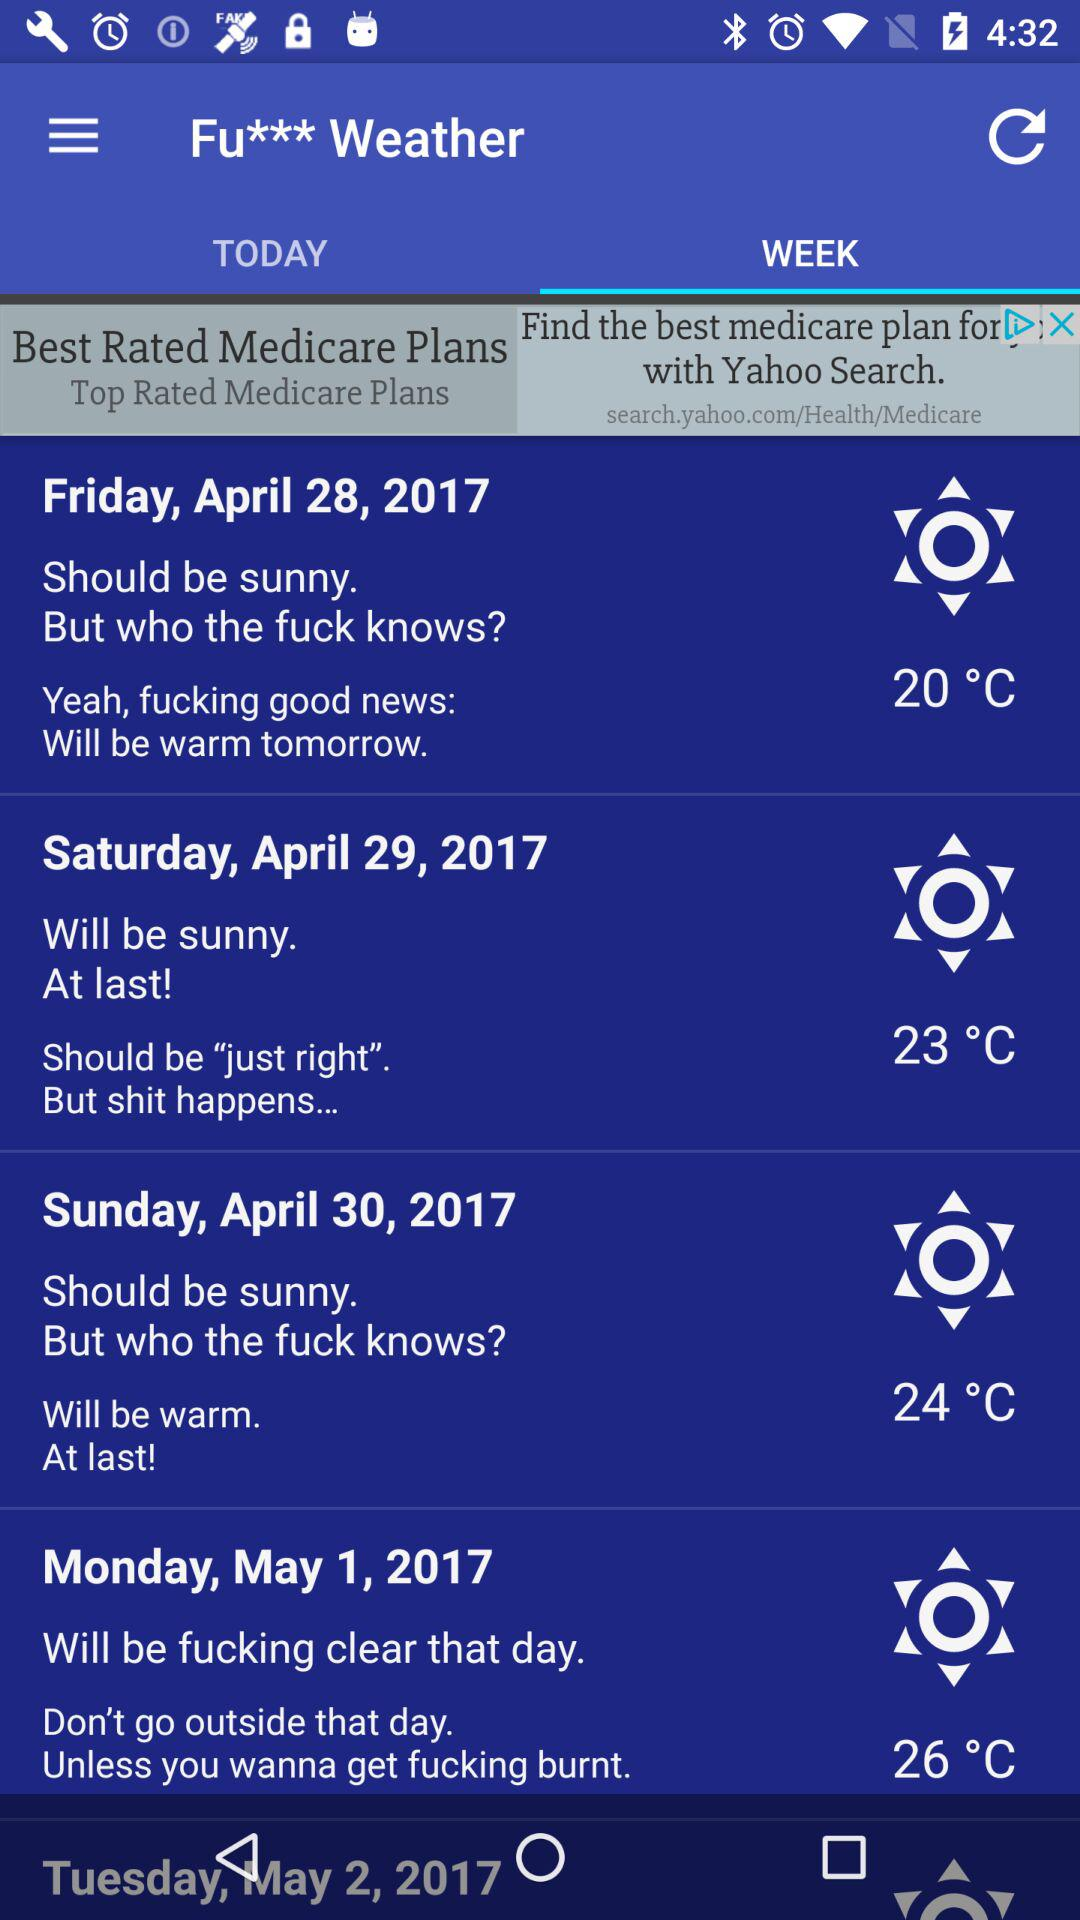What is the temperature on May 1? The temperature on May 1 is 26°C. 